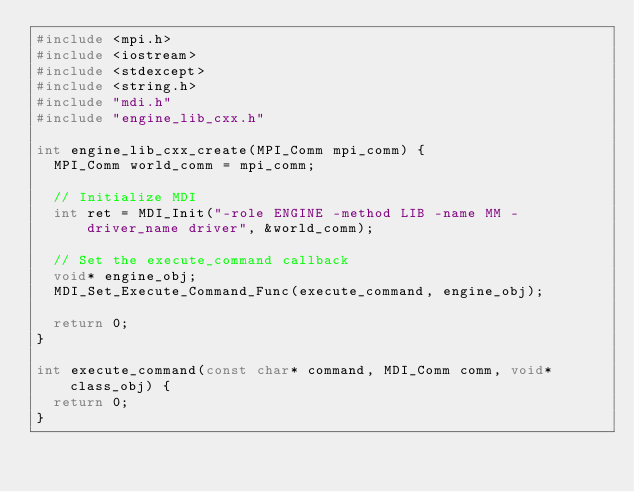Convert code to text. <code><loc_0><loc_0><loc_500><loc_500><_C++_>#include <mpi.h>
#include <iostream>
#include <stdexcept>
#include <string.h>
#include "mdi.h"
#include "engine_lib_cxx.h"

int engine_lib_cxx_create(MPI_Comm mpi_comm) {
  MPI_Comm world_comm = mpi_comm;

  // Initialize MDI
  int ret = MDI_Init("-role ENGINE -method LIB -name MM -driver_name driver", &world_comm);

  // Set the execute_command callback
  void* engine_obj;
  MDI_Set_Execute_Command_Func(execute_command, engine_obj);

  return 0;
}

int execute_command(const char* command, MDI_Comm comm, void* class_obj) {
  return 0;
}
</code> 